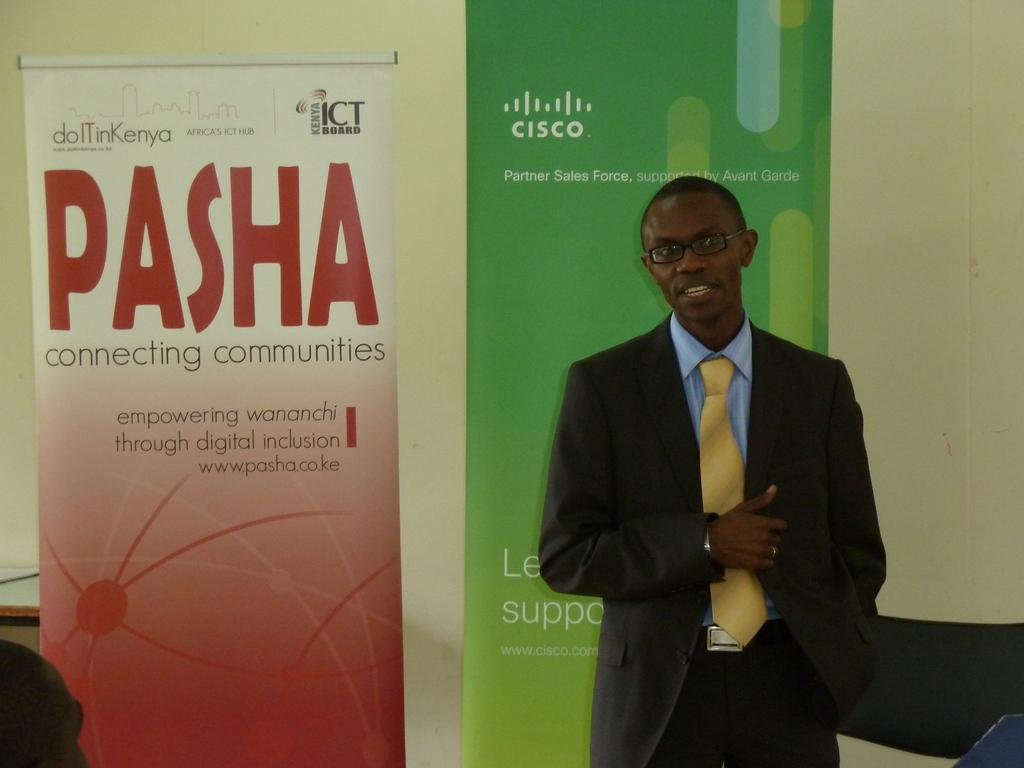<image>
Provide a brief description of the given image. An African American stands in front of two banners that read Pasha and the other Cisco. 